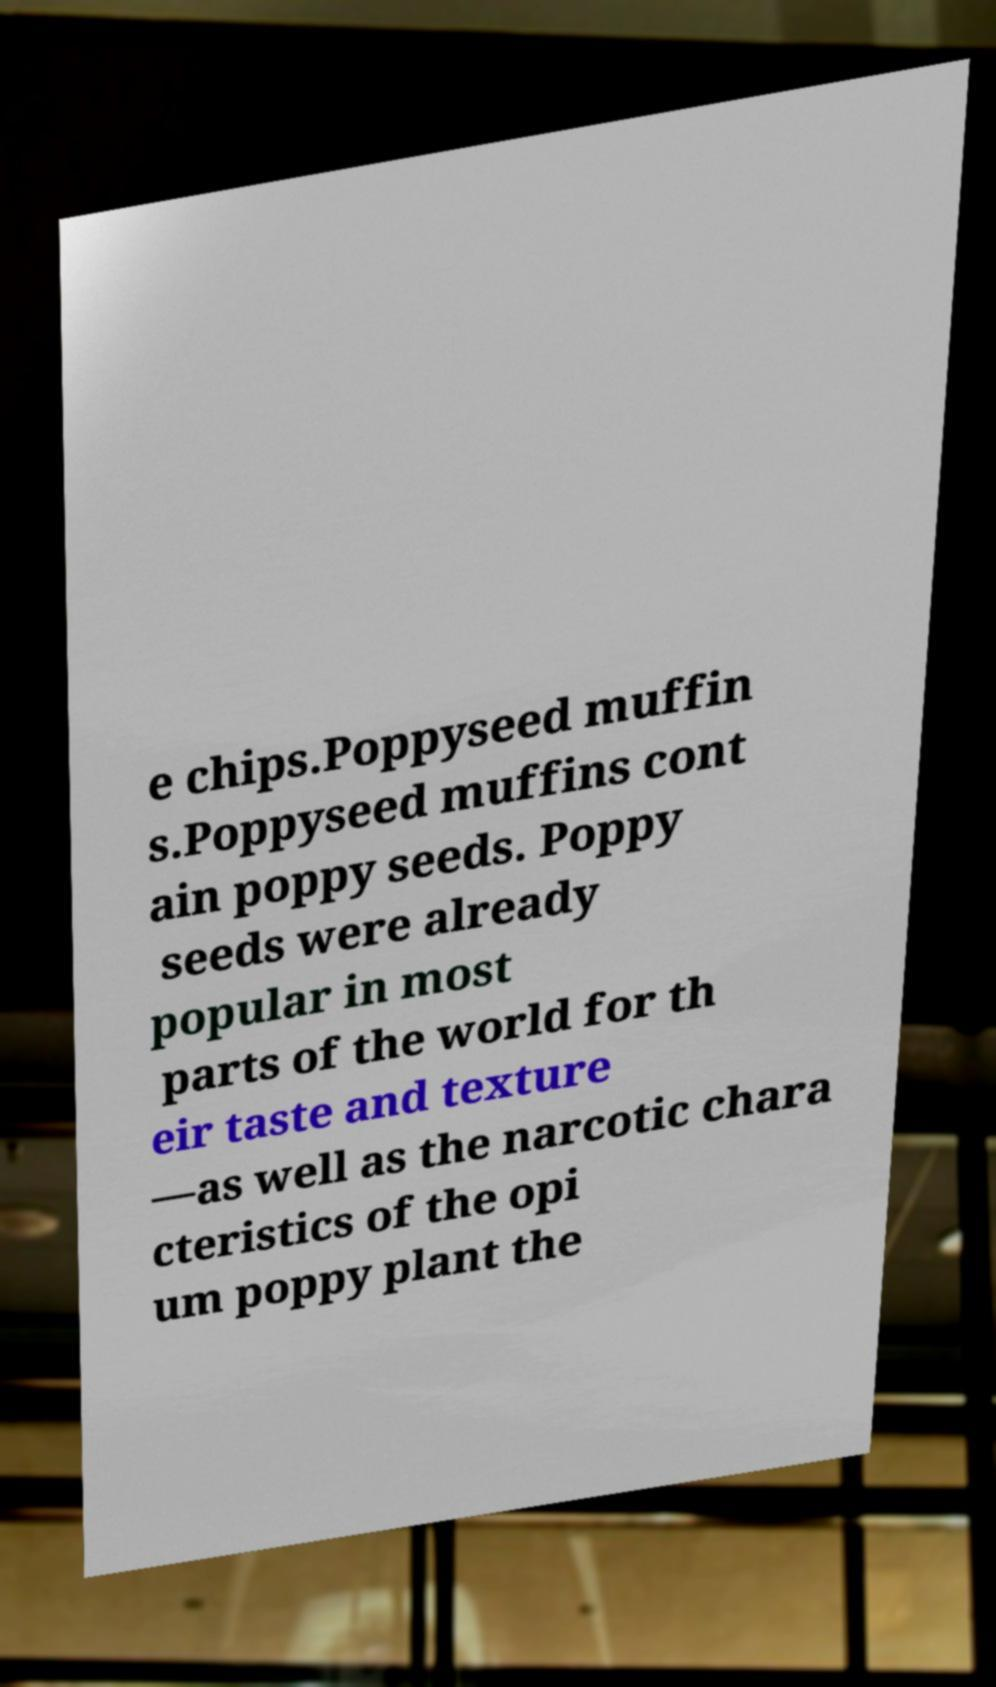Could you extract and type out the text from this image? e chips.Poppyseed muffin s.Poppyseed muffins cont ain poppy seeds. Poppy seeds were already popular in most parts of the world for th eir taste and texture —as well as the narcotic chara cteristics of the opi um poppy plant the 